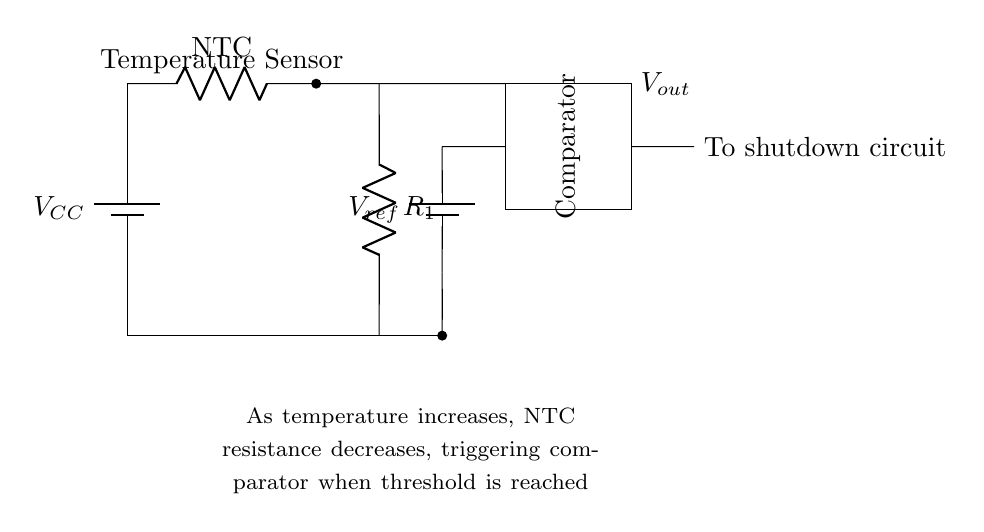What type of circuit is represented? The circuit is a thermal protection circuit designed to monitor temperature and trigger a shutdown under certain conditions.
Answer: Thermal protection circuit What is the role of the thermistor? The thermistor (NTC) decreases resistance as temperature increases, allowing it to act as a temperature sensor in the circuit.
Answer: Temperature sensor What component provides the reference voltage? The reference voltage is provided by the battery labeled as V ref, which sets a threshold for the comparator to trigger.
Answer: V ref How does the comparator operate in this circuit? The comparator compares the voltage from the voltage divider (R1 and thermistor) to the reference voltage when the NTC resistance changes with temperature. If the voltage exceeds V ref, it triggers a shutdown circuit.
Answer: It compares voltages What happens when the temperature exceeds the threshold? When the temperature exceeds the threshold set by the reference voltage, the comparator outputs a signal that activates the shutdown circuit to protect the system.
Answer: Activates shutdown circuit What happens to the NTC resistance as temperature increases? The NTC resistance decreases with increasing temperature, enabling the comparator to respond to temperature variations.
Answer: Decreases What voltage does the battery labeled VCC represent? The battery labeled VCC represents the supply voltage for the circuit components to operate, which is not specified in the diagram but is crucial for the circuit's functionality.
Answer: Supply voltage 